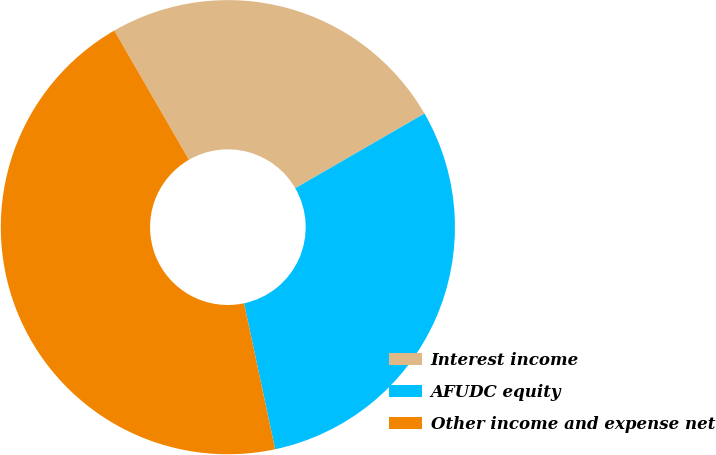Convert chart to OTSL. <chart><loc_0><loc_0><loc_500><loc_500><pie_chart><fcel>Interest income<fcel>AFUDC equity<fcel>Other income and expense net<nl><fcel>25.0%<fcel>30.0%<fcel>45.0%<nl></chart> 